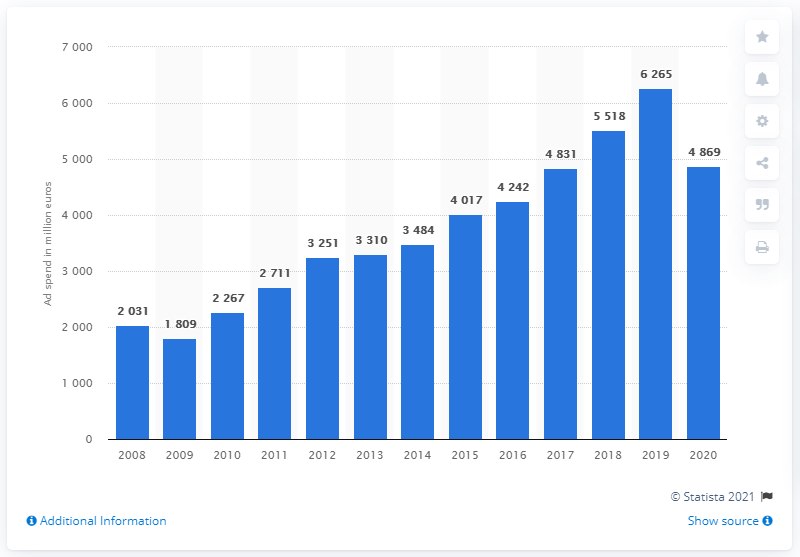Outline some significant characteristics in this image. LVMH Group's global advertising expenditure in 2020 was 4,869. 